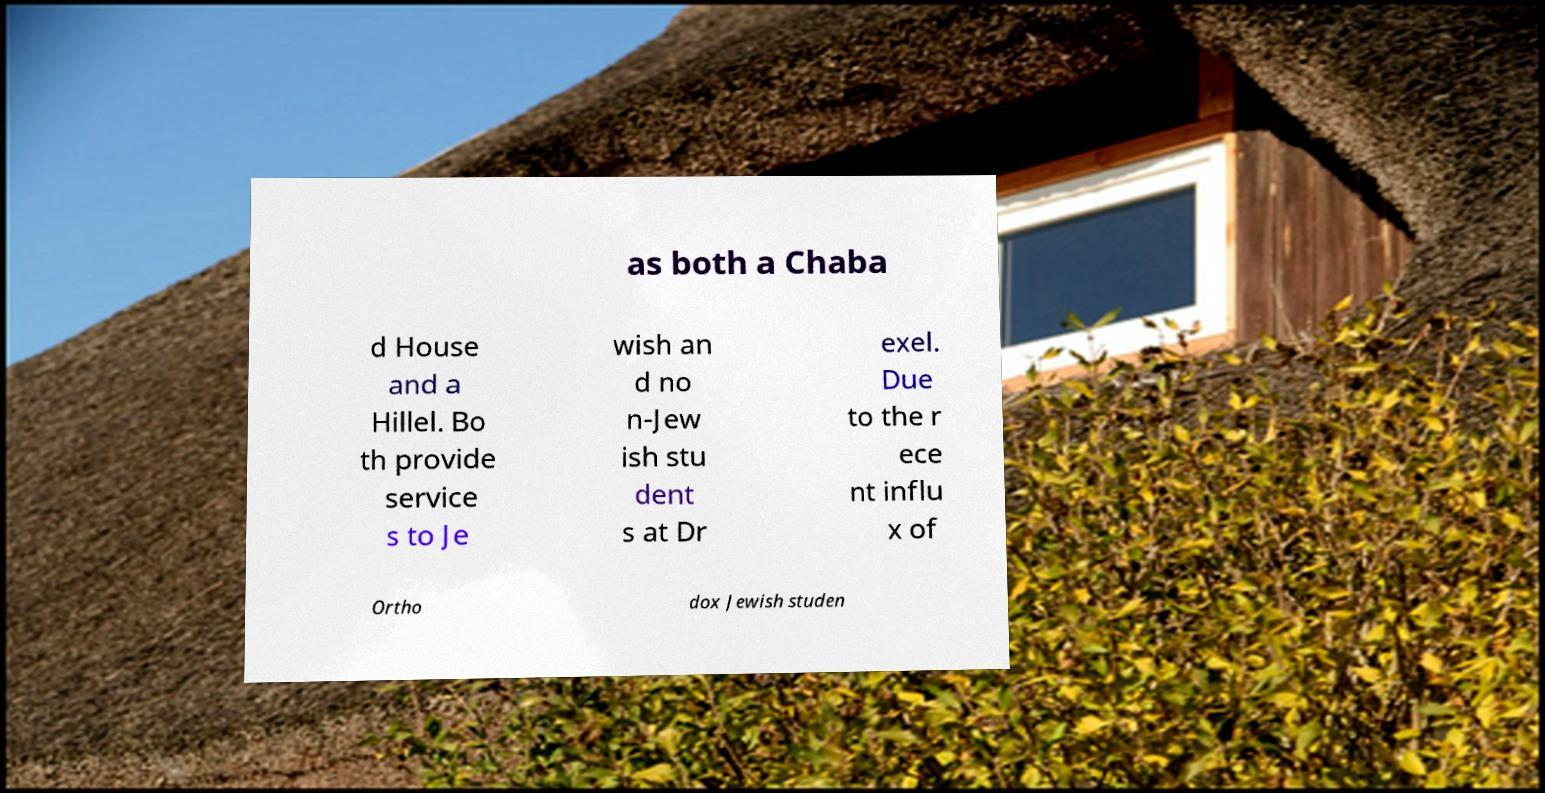What messages or text are displayed in this image? I need them in a readable, typed format. as both a Chaba d House and a Hillel. Bo th provide service s to Je wish an d no n-Jew ish stu dent s at Dr exel. Due to the r ece nt influ x of Ortho dox Jewish studen 